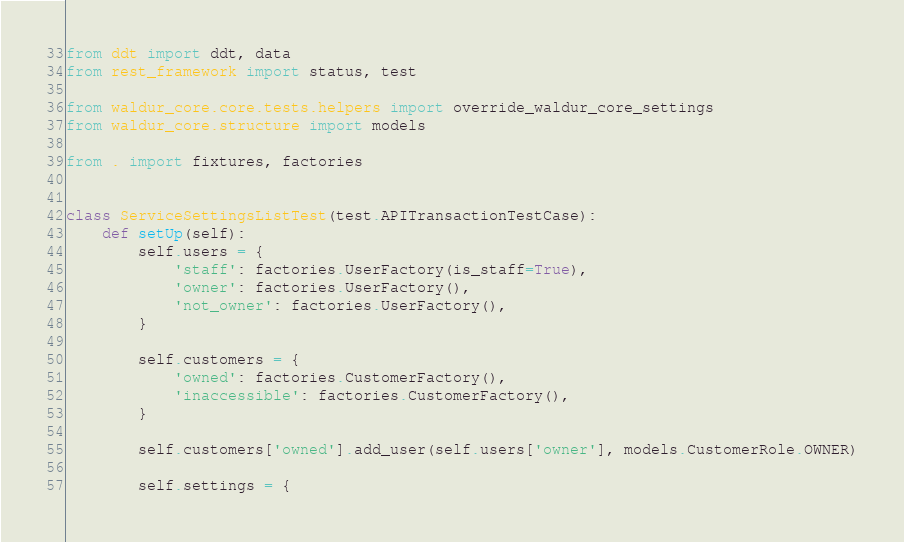Convert code to text. <code><loc_0><loc_0><loc_500><loc_500><_Python_>from ddt import ddt, data
from rest_framework import status, test

from waldur_core.core.tests.helpers import override_waldur_core_settings
from waldur_core.structure import models

from . import fixtures, factories


class ServiceSettingsListTest(test.APITransactionTestCase):
    def setUp(self):
        self.users = {
            'staff': factories.UserFactory(is_staff=True),
            'owner': factories.UserFactory(),
            'not_owner': factories.UserFactory(),
        }

        self.customers = {
            'owned': factories.CustomerFactory(),
            'inaccessible': factories.CustomerFactory(),
        }

        self.customers['owned'].add_user(self.users['owner'], models.CustomerRole.OWNER)

        self.settings = {</code> 